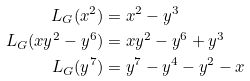Convert formula to latex. <formula><loc_0><loc_0><loc_500><loc_500>L _ { G } ( x ^ { 2 } ) & = x ^ { 2 } - y ^ { 3 } \\ L _ { G } ( x y ^ { 2 } - y ^ { 6 } ) & = x y ^ { 2 } - y ^ { 6 } + y ^ { 3 } \\ L _ { G } ( y ^ { 7 } ) & = y ^ { 7 } - y ^ { 4 } - y ^ { 2 } - x</formula> 